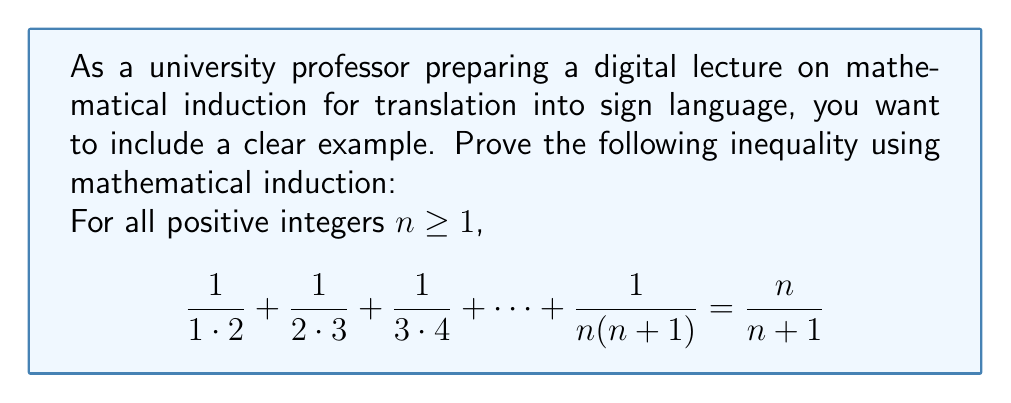Show me your answer to this math problem. To prove this inequality using mathematical induction, we'll follow these steps:

1) Base case: Prove the statement is true for $n = 1$.
2) Inductive step: Assume the statement is true for some $k \geq 1$, then prove it's true for $k+1$.

Step 1: Base case $(n = 1)$
For $n = 1$, the left side of the equation is:
$$ \frac{1}{1 \cdot 2} = \frac{1}{2} $$
The right side is:
$$ \frac{1}{1+1} = \frac{1}{2} $$
Thus, the statement is true for $n = 1$.

Step 2: Inductive step
Assume the statement is true for some $k \geq 1$. That is:
$$ \frac{1}{1 \cdot 2} + \frac{1}{2 \cdot 3} + \frac{1}{3 \cdot 4} + \cdots + \frac{1}{k(k+1)} = \frac{k}{k+1} $$

Now, we need to prove it's true for $k+1$:
$$ \frac{1}{1 \cdot 2} + \frac{1}{2 \cdot 3} + \frac{1}{3 \cdot 4} + \cdots + \frac{1}{k(k+1)} + \frac{1}{(k+1)(k+2)} \stackrel{?}{=} \frac{k+1}{k+2} $$

Let's start with the left side:
$$ \left(\frac{1}{1 \cdot 2} + \frac{1}{2 \cdot 3} + \frac{1}{3 \cdot 4} + \cdots + \frac{1}{k(k+1)}\right) + \frac{1}{(k+1)(k+2)} $$

Using our inductive hypothesis, we can replace the part in parentheses:
$$ \frac{k}{k+1} + \frac{1}{(k+1)(k+2)} $$

Now, let's find a common denominator:
$$ \frac{k(k+2)}{(k+1)(k+2)} + \frac{1}{(k+1)(k+2)} = \frac{k(k+2)+1}{(k+1)(k+2)} $$

Simplify the numerator:
$$ \frac{k^2+2k+1}{(k+1)(k+2)} = \frac{(k+1)^2}{(k+1)(k+2)} = \frac{k+1}{k+2} $$

This is exactly what we wanted to prove for $k+1$.

Therefore, by the principle of mathematical induction, the statement is true for all positive integers $n \geq 1$.
Answer: The inequality is proven true for all positive integers $n \geq 1$ using mathematical induction. 